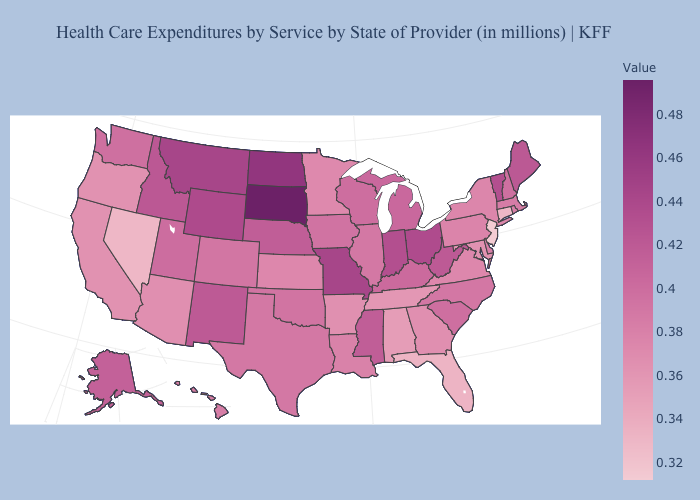Does Vermont have a higher value than South Dakota?
Answer briefly. No. Among the states that border Iowa , does South Dakota have the highest value?
Give a very brief answer. Yes. Does the map have missing data?
Keep it brief. No. 